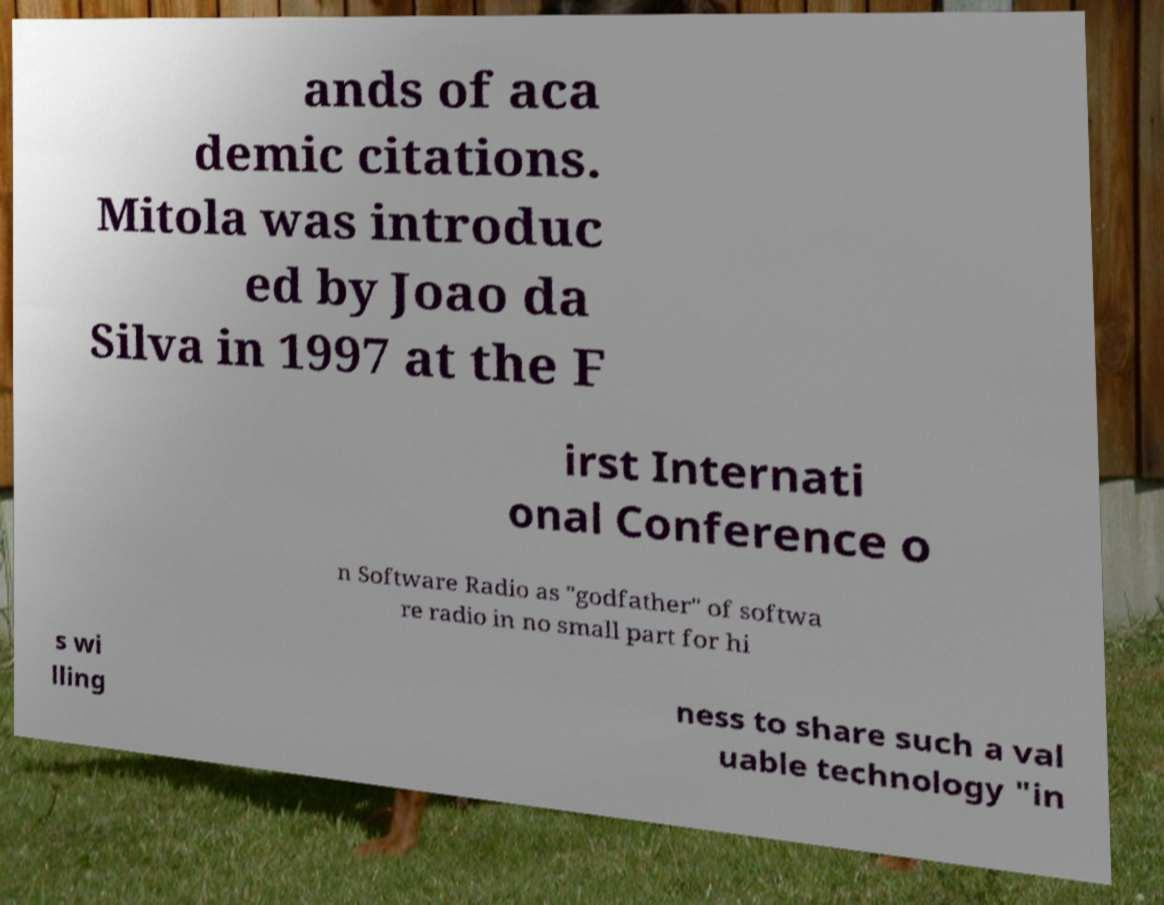Please identify and transcribe the text found in this image. ands of aca demic citations. Mitola was introduc ed by Joao da Silva in 1997 at the F irst Internati onal Conference o n Software Radio as "godfather" of softwa re radio in no small part for hi s wi lling ness to share such a val uable technology "in 